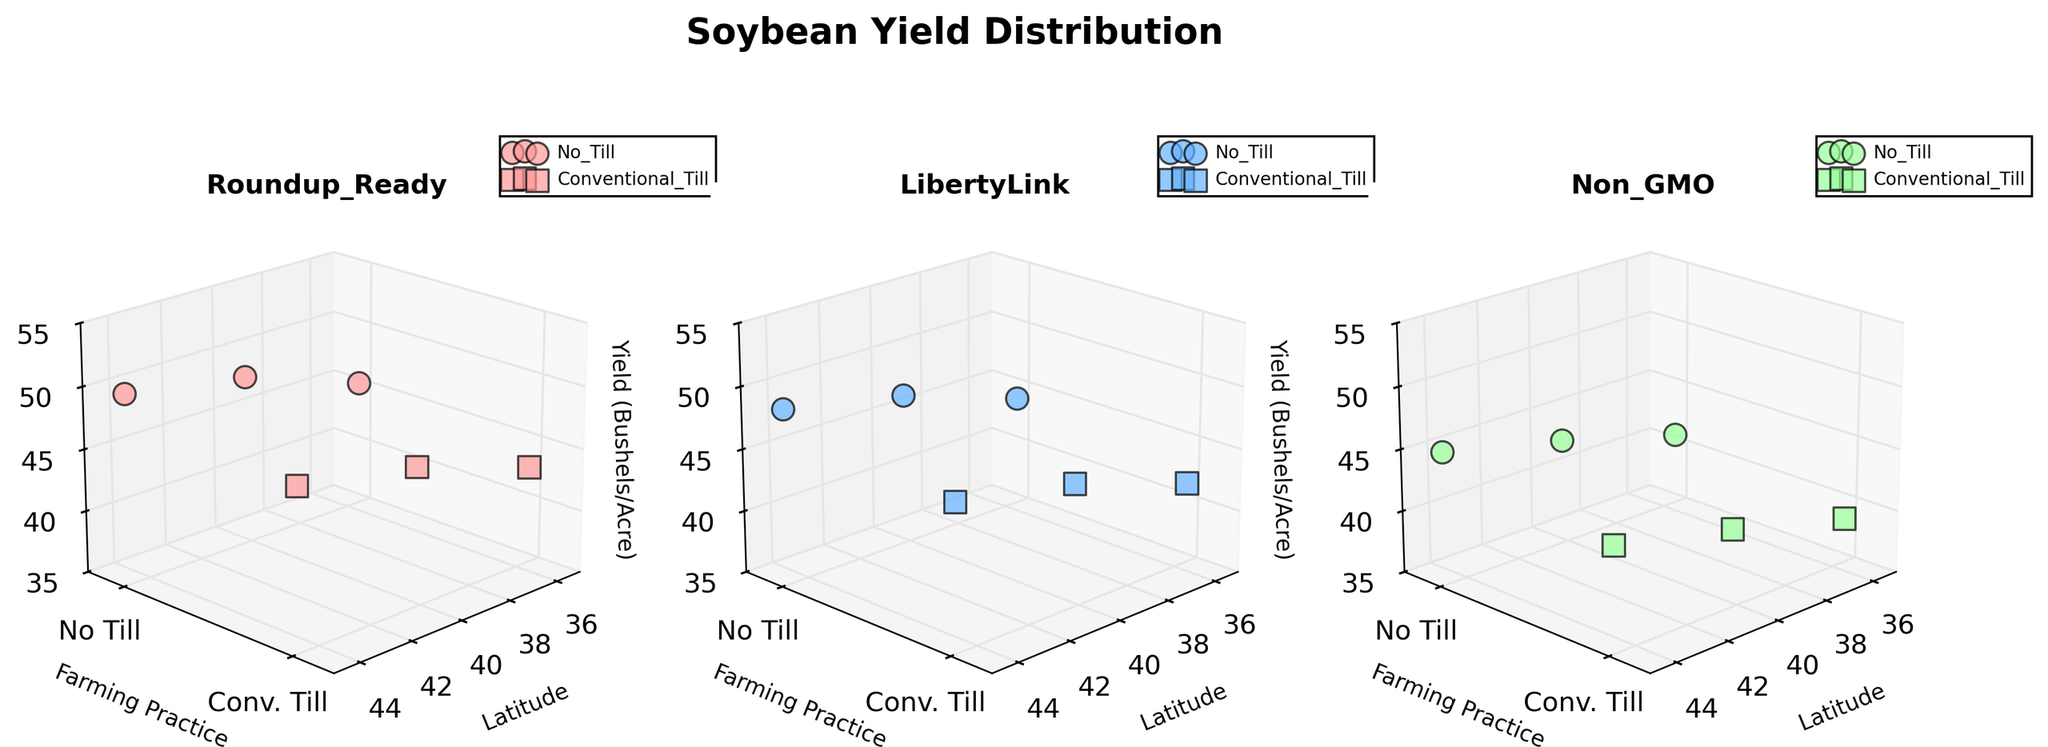How many subplots are present in the figure? By looking at the figure, one can see three subplots aligned horizontally, each representing one of the genetic modification types.
Answer: Three What are the axes labels in the subplots? In each subplot, the axes labels are "Latitude" for the x-axis, "Farming Practice" for the y-axis, and "Yield (Bushels/Acre)" for the z-axis.
Answer: Latitude, Farming Practice, Yield (Bushels/Acre) Which genetic modification shows the highest yield under No Till practice at latitude 44.8? In the subplot corresponding to each genetic modification, observe the No Till data points at latitude 44.8. The Roundup_Ready subplot shows the highest yield (50.3 bushels per acre).
Answer: Roundup_Ready What is the yield difference between No Till and Conventional Till farming practices for LibertyLink at latitude 40.2? In the LibertyLink subplot, compare the yield values at latitude 40.2 where No Till is 47.2 and Conventional Till is 44.8. The difference is 47.2 - 44.8 = 2.4.
Answer: 2.4 Which farming practice generally leads to higher yields for Non_GMO soybeans at latitude 35.5? In the Non_GMO subplot, compare the yields of No Till and Conventional Till at latitude 35.5. No Till has a yield of 40.8 while Conventional Till has a yield of 38.6. No Till is higher.
Answer: No Till At which latitude does the Soybean yield with Roundup_Ready genetic modification show the greatest increase when switching from Conventional Till to No Till? Examine the Roundup_Ready subplot and compare yields at each latitude when switching from Conventional Till to No Till. The greatest increase is at latitude 44.8 with yields of 47.9 (Conventional) and 50.3 (No Till), an increase of 2.4.
Answer: 44.8 Compare the yields of Roundup_Ready and Non_GMO soybeans under No Till at latitude 40.2. Which one is higher and by how much? Look at the No Till yield values at latitude 40.2 in the subplots for Roundup_Ready and Non_GMO. Roundup_Ready yield is 48.7, and Non_GMO yield is 43.5. The difference is 48.7 - 43.5 = 5.2, with Roundup_Ready being higher.
Answer: Roundup_Ready, by 5.2 Which subplot shows the yields of LibertyLink genetic modification? The title of each subplot indicates the genetic modification type. The subplot titled "LibertyLink" shows the yields for LibertyLink.
Answer: LibertyLink What trend in yield can be observed across different latitudes for Non_GMO soybeans under No Till farming? Observe the No Till data points in the Non_GMO subplot across latitudes 35.5, 40.2, and 44.8. The yield increases from 40.8 to 43.5 to 45.7 as latitude increases.
Answer: Increasing trend 